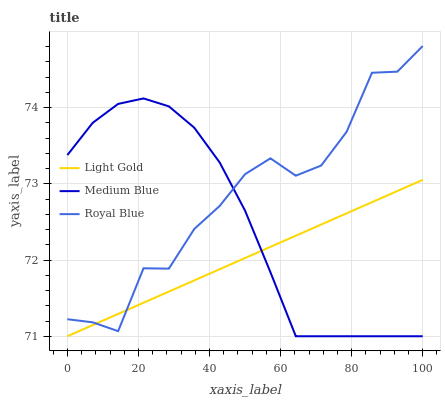Does Light Gold have the minimum area under the curve?
Answer yes or no. Yes. Does Royal Blue have the maximum area under the curve?
Answer yes or no. Yes. Does Royal Blue have the minimum area under the curve?
Answer yes or no. No. Does Light Gold have the maximum area under the curve?
Answer yes or no. No. Is Light Gold the smoothest?
Answer yes or no. Yes. Is Royal Blue the roughest?
Answer yes or no. Yes. Is Royal Blue the smoothest?
Answer yes or no. No. Is Light Gold the roughest?
Answer yes or no. No. Does Medium Blue have the lowest value?
Answer yes or no. Yes. Does Royal Blue have the lowest value?
Answer yes or no. No. Does Royal Blue have the highest value?
Answer yes or no. Yes. Does Light Gold have the highest value?
Answer yes or no. No. Does Royal Blue intersect Light Gold?
Answer yes or no. Yes. Is Royal Blue less than Light Gold?
Answer yes or no. No. Is Royal Blue greater than Light Gold?
Answer yes or no. No. 